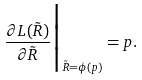Convert formula to latex. <formula><loc_0><loc_0><loc_500><loc_500>\frac { \partial L ( \tilde { R } ) } { \partial \tilde { R } } \Big { | } _ { \tilde { R } = \phi ( p ) } = p .</formula> 